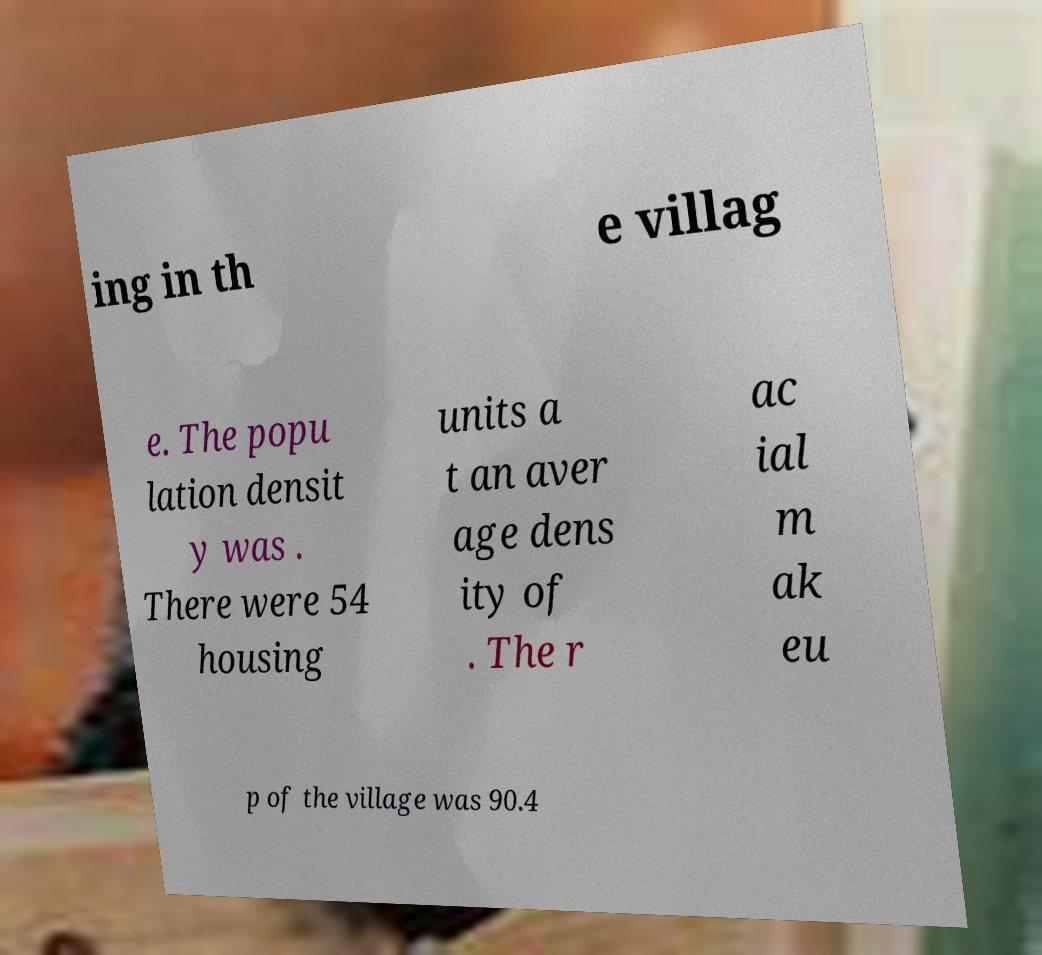There's text embedded in this image that I need extracted. Can you transcribe it verbatim? ing in th e villag e. The popu lation densit y was . There were 54 housing units a t an aver age dens ity of . The r ac ial m ak eu p of the village was 90.4 